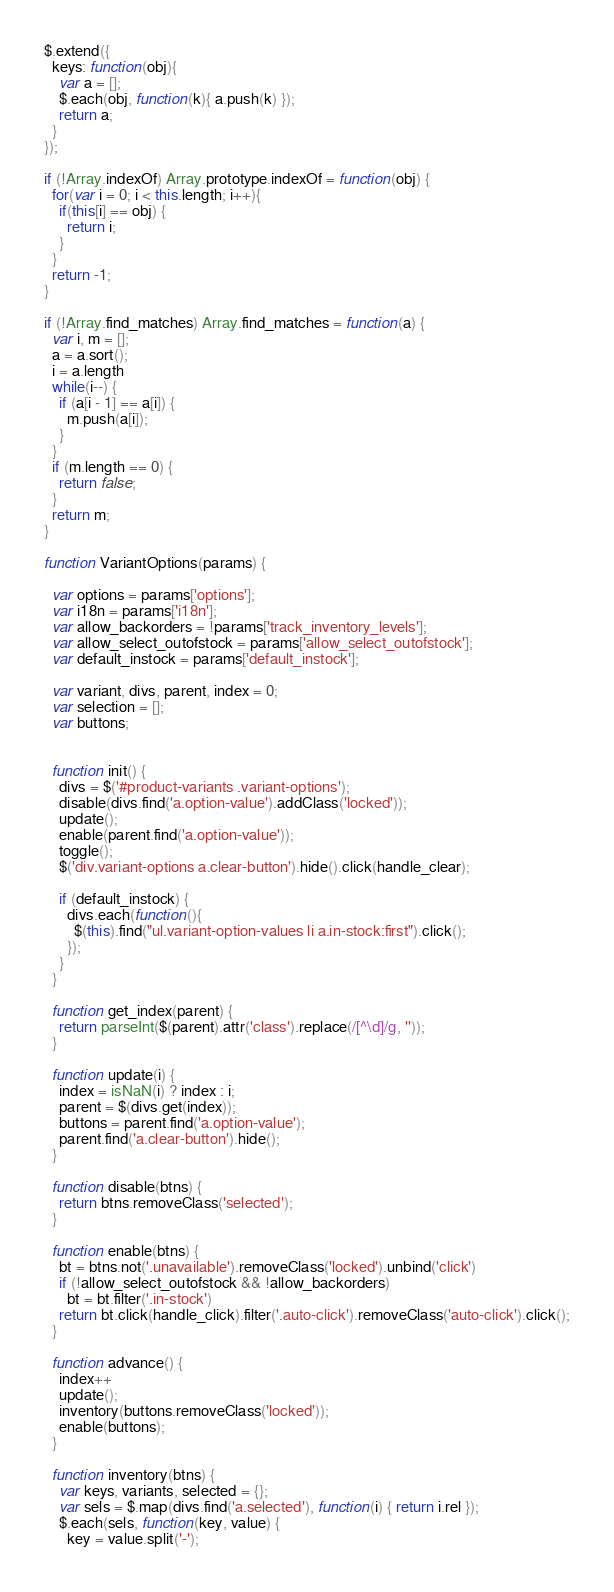<code> <loc_0><loc_0><loc_500><loc_500><_JavaScript_>$.extend({
  keys: function(obj){
    var a = [];
    $.each(obj, function(k){ a.push(k) });
    return a;
  }
});

if (!Array.indexOf) Array.prototype.indexOf = function(obj) {
  for(var i = 0; i < this.length; i++){
    if(this[i] == obj) {
      return i;
    }
  }
  return -1;
}

if (!Array.find_matches) Array.find_matches = function(a) {
  var i, m = [];
  a = a.sort();
  i = a.length
  while(i--) {
    if (a[i - 1] == a[i]) {
      m.push(a[i]);
    }
  }
  if (m.length == 0) {
    return false;
  }
  return m;
}

function VariantOptions(params) {

  var options = params['options'];
  var i18n = params['i18n'];
  var allow_backorders = !params['track_inventory_levels'];
  var allow_select_outofstock = params['allow_select_outofstock'];
  var default_instock = params['default_instock'];

  var variant, divs, parent, index = 0;
  var selection = [];
  var buttons;


  function init() {
    divs = $('#product-variants .variant-options');
    disable(divs.find('a.option-value').addClass('locked'));
    update();
    enable(parent.find('a.option-value'));
    toggle();
    $('div.variant-options a.clear-button').hide().click(handle_clear);

    if (default_instock) {
      divs.each(function(){
        $(this).find("ul.variant-option-values li a.in-stock:first").click();
      });
    }
  }

  function get_index(parent) {
    return parseInt($(parent).attr('class').replace(/[^\d]/g, ''));
  }

  function update(i) {
    index = isNaN(i) ? index : i;
    parent = $(divs.get(index));
    buttons = parent.find('a.option-value');
    parent.find('a.clear-button').hide();
  }

  function disable(btns) {
    return btns.removeClass('selected');
  }

  function enable(btns) {
    bt = btns.not('.unavailable').removeClass('locked').unbind('click')
    if (!allow_select_outofstock && !allow_backorders)
      bt = bt.filter('.in-stock')
    return bt.click(handle_click).filter('.auto-click').removeClass('auto-click').click();
  }

  function advance() {
    index++
    update();
    inventory(buttons.removeClass('locked'));
    enable(buttons);
  }

  function inventory(btns) {
    var keys, variants, selected = {};
    var sels = $.map(divs.find('a.selected'), function(i) { return i.rel });
    $.each(sels, function(key, value) {
      key = value.split('-');</code> 